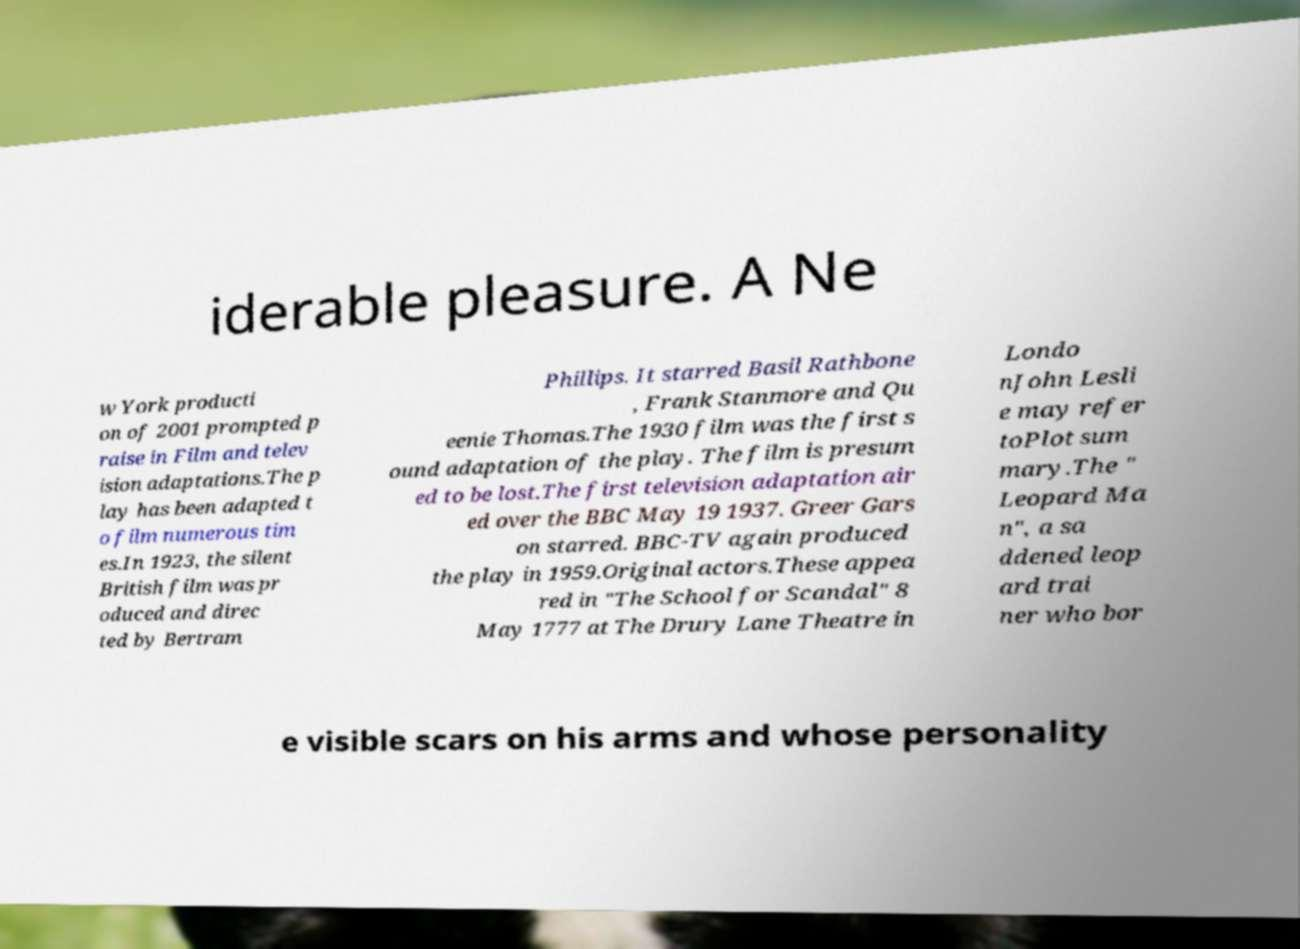What messages or text are displayed in this image? I need them in a readable, typed format. iderable pleasure. A Ne w York producti on of 2001 prompted p raise in Film and telev ision adaptations.The p lay has been adapted t o film numerous tim es.In 1923, the silent British film was pr oduced and direc ted by Bertram Phillips. It starred Basil Rathbone , Frank Stanmore and Qu eenie Thomas.The 1930 film was the first s ound adaptation of the play. The film is presum ed to be lost.The first television adaptation air ed over the BBC May 19 1937. Greer Gars on starred. BBC-TV again produced the play in 1959.Original actors.These appea red in "The School for Scandal" 8 May 1777 at The Drury Lane Theatre in Londo nJohn Lesli e may refer toPlot sum mary.The " Leopard Ma n", a sa ddened leop ard trai ner who bor e visible scars on his arms and whose personality 